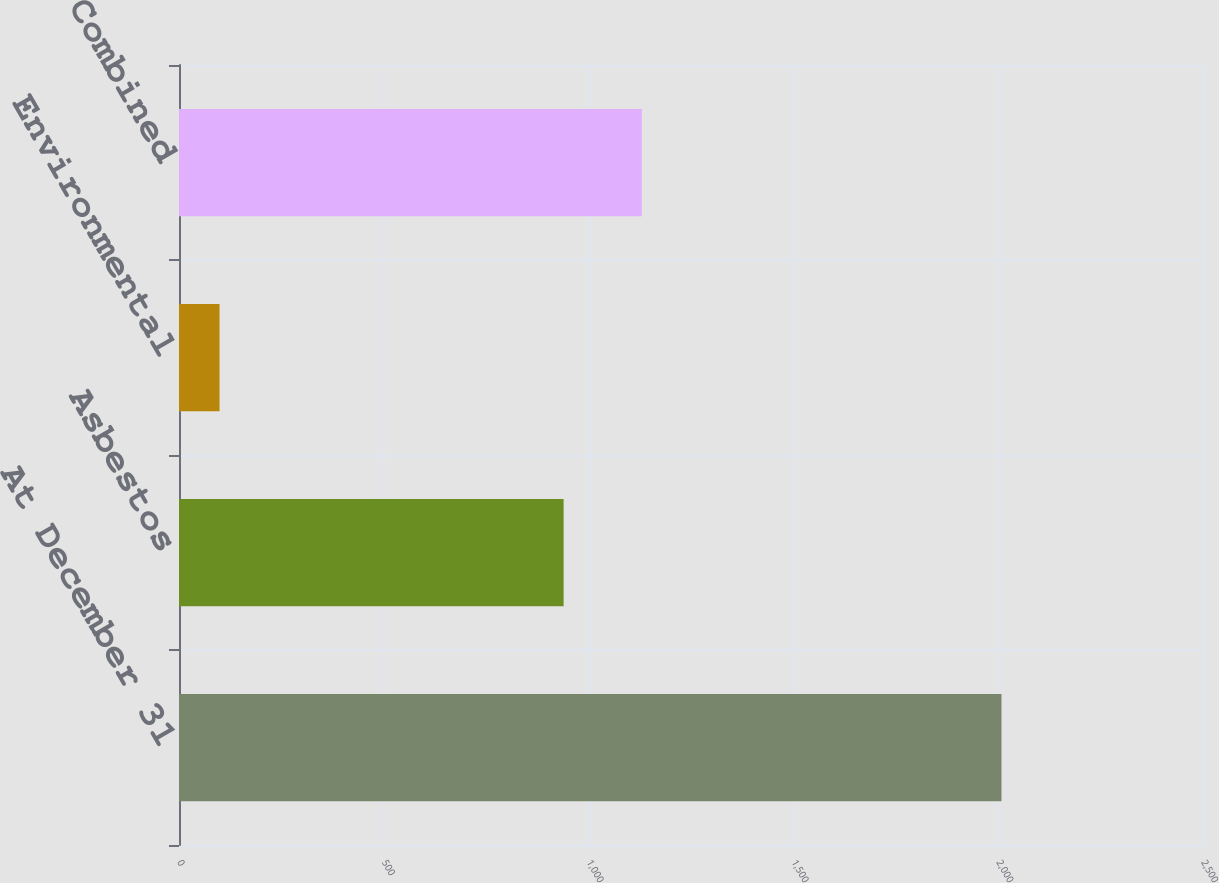Convert chart to OTSL. <chart><loc_0><loc_0><loc_500><loc_500><bar_chart><fcel>At December 31<fcel>Asbestos<fcel>Environmental<fcel>Combined<nl><fcel>2008<fcel>939<fcel>99<fcel>1129.9<nl></chart> 